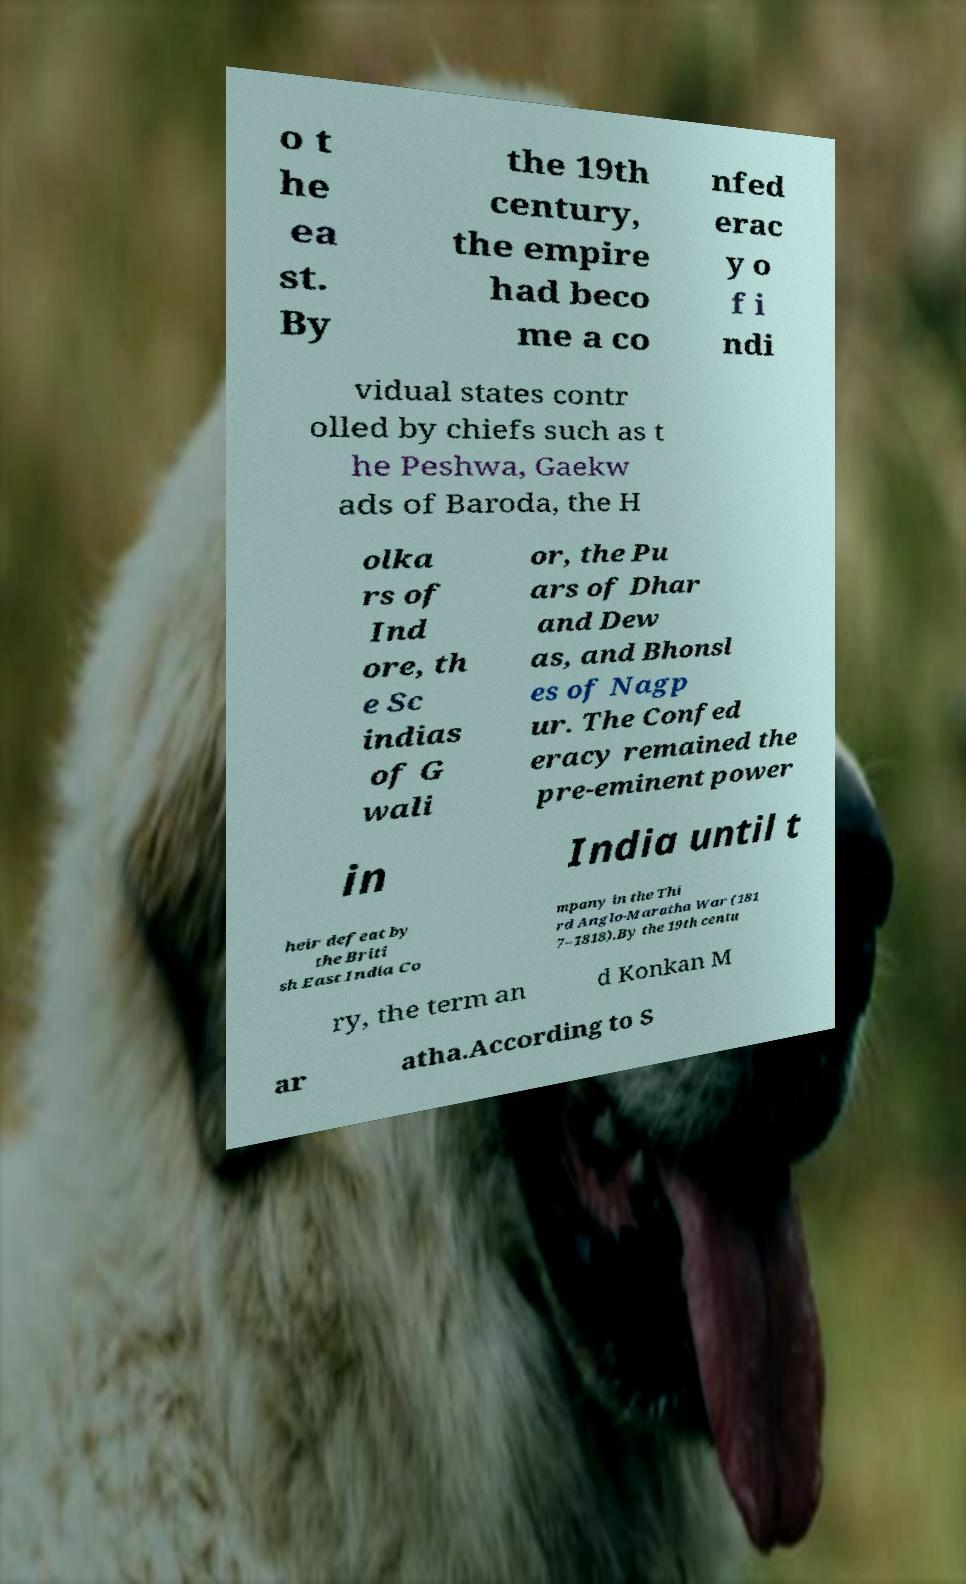For documentation purposes, I need the text within this image transcribed. Could you provide that? o t he ea st. By the 19th century, the empire had beco me a co nfed erac y o f i ndi vidual states contr olled by chiefs such as t he Peshwa, Gaekw ads of Baroda, the H olka rs of Ind ore, th e Sc indias of G wali or, the Pu ars of Dhar and Dew as, and Bhonsl es of Nagp ur. The Confed eracy remained the pre-eminent power in India until t heir defeat by the Briti sh East India Co mpany in the Thi rd Anglo-Maratha War (181 7–1818).By the 19th centu ry, the term an d Konkan M ar atha.According to S 